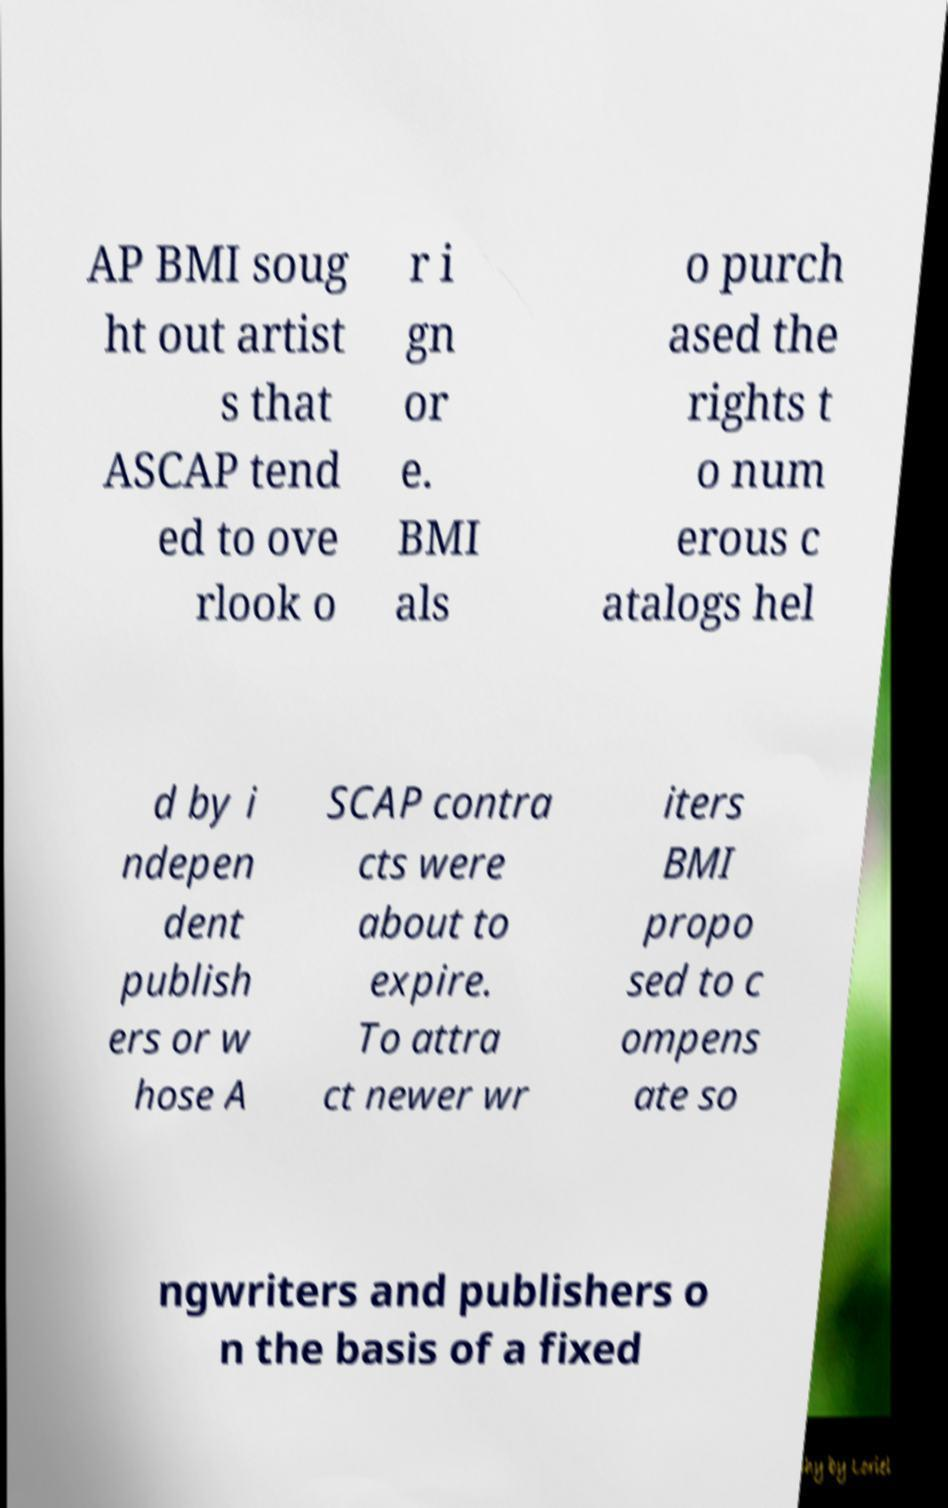For documentation purposes, I need the text within this image transcribed. Could you provide that? AP BMI soug ht out artist s that ASCAP tend ed to ove rlook o r i gn or e. BMI als o purch ased the rights t o num erous c atalogs hel d by i ndepen dent publish ers or w hose A SCAP contra cts were about to expire. To attra ct newer wr iters BMI propo sed to c ompens ate so ngwriters and publishers o n the basis of a fixed 